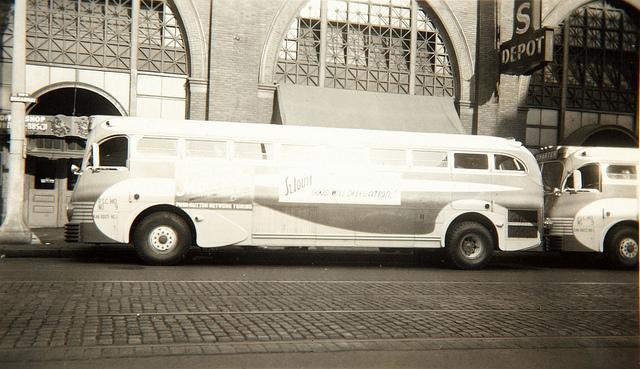How many wheels are there?
Give a very brief answer. 3. How many buses are there?
Give a very brief answer. 2. 